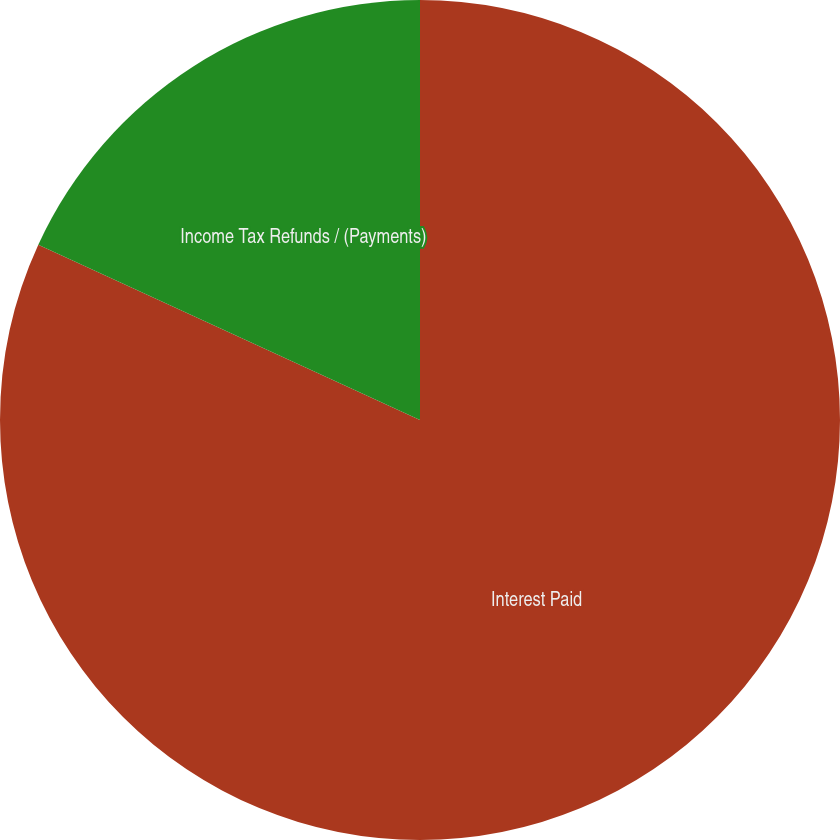<chart> <loc_0><loc_0><loc_500><loc_500><pie_chart><fcel>Interest Paid<fcel>Income Tax Refunds / (Payments)<nl><fcel>81.85%<fcel>18.15%<nl></chart> 